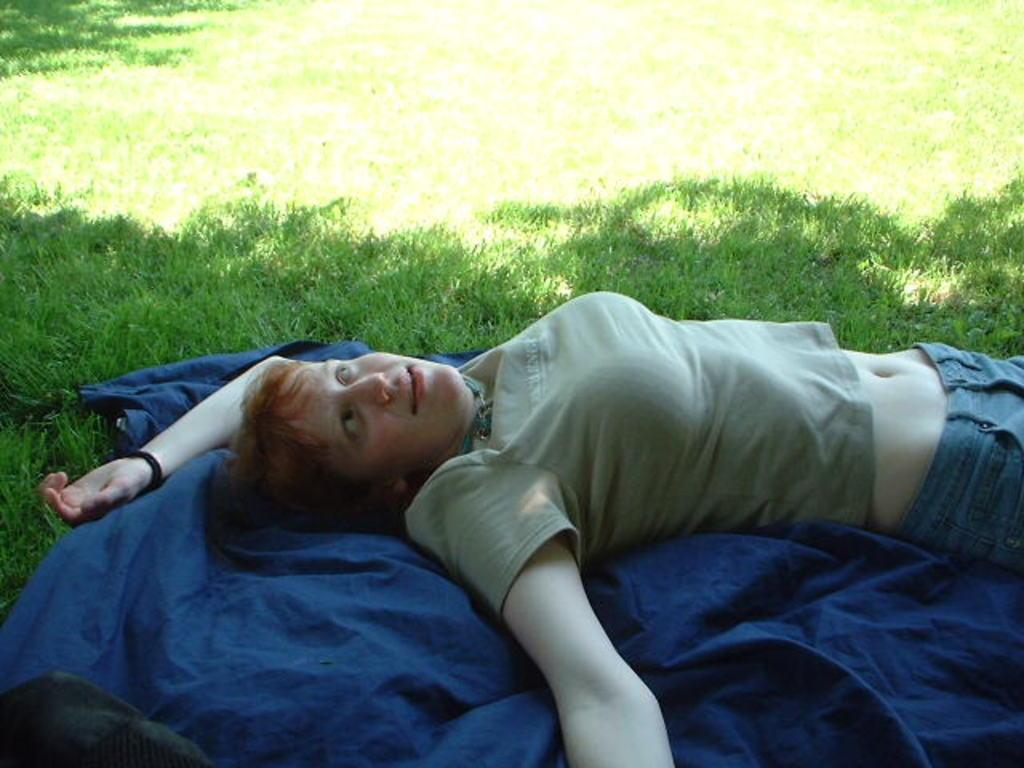Describe this image in one or two sentences. In this image I can see a woman is lying on a blue colored cloth. Here I can see the grass. The woman is wearing a T-shirt. 